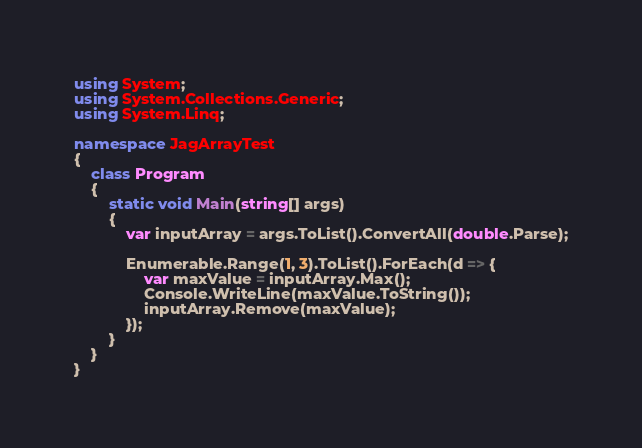Convert code to text. <code><loc_0><loc_0><loc_500><loc_500><_C#_>using System;
using System.Collections.Generic;
using System.Linq;

namespace JagArrayTest
{
    class Program
    {
        static void Main(string[] args)
        {
            var inputArray = args.ToList().ConvertAll(double.Parse);

            Enumerable.Range(1, 3).ToList().ForEach(d => {
                var maxValue = inputArray.Max();
                Console.WriteLine(maxValue.ToString());
                inputArray.Remove(maxValue);
            });
        }
    }
}
</code> 